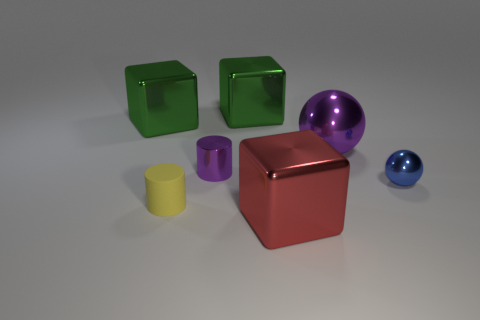What is the color of the cube in front of the big green thing that is on the left side of the cylinder that is behind the small blue sphere?
Offer a terse response. Red. What number of other things are the same color as the small ball?
Make the answer very short. 0. How many rubber things are either cylinders or blue spheres?
Give a very brief answer. 1. Is the color of the shiny object that is in front of the tiny blue shiny ball the same as the cylinder behind the small yellow cylinder?
Ensure brevity in your answer.  No. Are there any other things that have the same material as the yellow thing?
Give a very brief answer. No. What size is the purple metallic thing that is the same shape as the rubber thing?
Offer a very short reply. Small. Is the number of objects that are to the left of the large red metallic cube greater than the number of blocks?
Provide a succinct answer. Yes. Do the small purple thing that is behind the big red cube and the tiny yellow object have the same material?
Give a very brief answer. No. There is a green metallic block on the left side of the metallic cube behind the green metal object that is left of the shiny cylinder; how big is it?
Keep it short and to the point. Large. The purple ball that is made of the same material as the small purple thing is what size?
Provide a succinct answer. Large. 